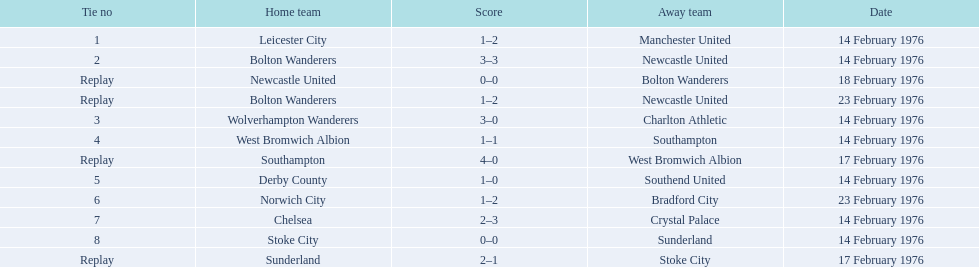Which teams participated in the game? Leicester City, Manchester United, Bolton Wanderers, Newcastle United, Newcastle United, Bolton Wanderers, Bolton Wanderers, Newcastle United, Wolverhampton Wanderers, Charlton Athletic, West Bromwich Albion, Southampton, Southampton, West Bromwich Albion, Derby County, Southend United, Norwich City, Bradford City, Chelsea, Crystal Palace, Stoke City, Sunderland, Sunderland, Stoke City. Which team emerged victorious? Manchester United, Newcastle United, Wolverhampton Wanderers, Southampton, Derby County, Bradford City, Crystal Palace, Sunderland. What was manchester united's winning score? 1–2. Write the full table. {'header': ['Tie no', 'Home team', 'Score', 'Away team', 'Date'], 'rows': [['1', 'Leicester City', '1–2', 'Manchester United', '14 February 1976'], ['2', 'Bolton Wanderers', '3–3', 'Newcastle United', '14 February 1976'], ['Replay', 'Newcastle United', '0–0', 'Bolton Wanderers', '18 February 1976'], ['Replay', 'Bolton Wanderers', '1–2', 'Newcastle United', '23 February 1976'], ['3', 'Wolverhampton Wanderers', '3–0', 'Charlton Athletic', '14 February 1976'], ['4', 'West Bromwich Albion', '1–1', 'Southampton', '14 February 1976'], ['Replay', 'Southampton', '4–0', 'West Bromwich Albion', '17 February 1976'], ['5', 'Derby County', '1–0', 'Southend United', '14 February 1976'], ['6', 'Norwich City', '1–2', 'Bradford City', '23 February 1976'], ['7', 'Chelsea', '2–3', 'Crystal Palace', '14 February 1976'], ['8', 'Stoke City', '0–0', 'Sunderland', '14 February 1976'], ['Replay', 'Sunderland', '2–1', 'Stoke City', '17 February 1976']]} What was wolverhampton wanderers' winning score? 3–0. Which of these two teams had a superior winning score? Wolverhampton Wanderers. 